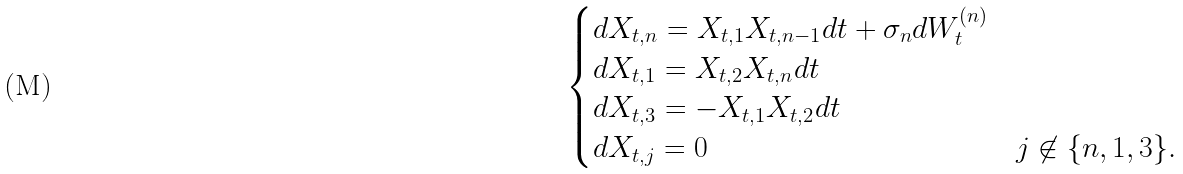<formula> <loc_0><loc_0><loc_500><loc_500>\begin{cases} d X _ { t , n } = X _ { t , 1 } X _ { t , n - 1 } d t + \sigma _ { n } d W _ { t } ^ { ( n ) } \\ d X _ { t , 1 } = X _ { t , 2 } X _ { t , n } d t \\ d X _ { t , 3 } = - X _ { t , 1 } X _ { t , 2 } d t \\ d X _ { t , j } = 0 & j \not \in \{ n , 1 , 3 \} . \end{cases}</formula> 